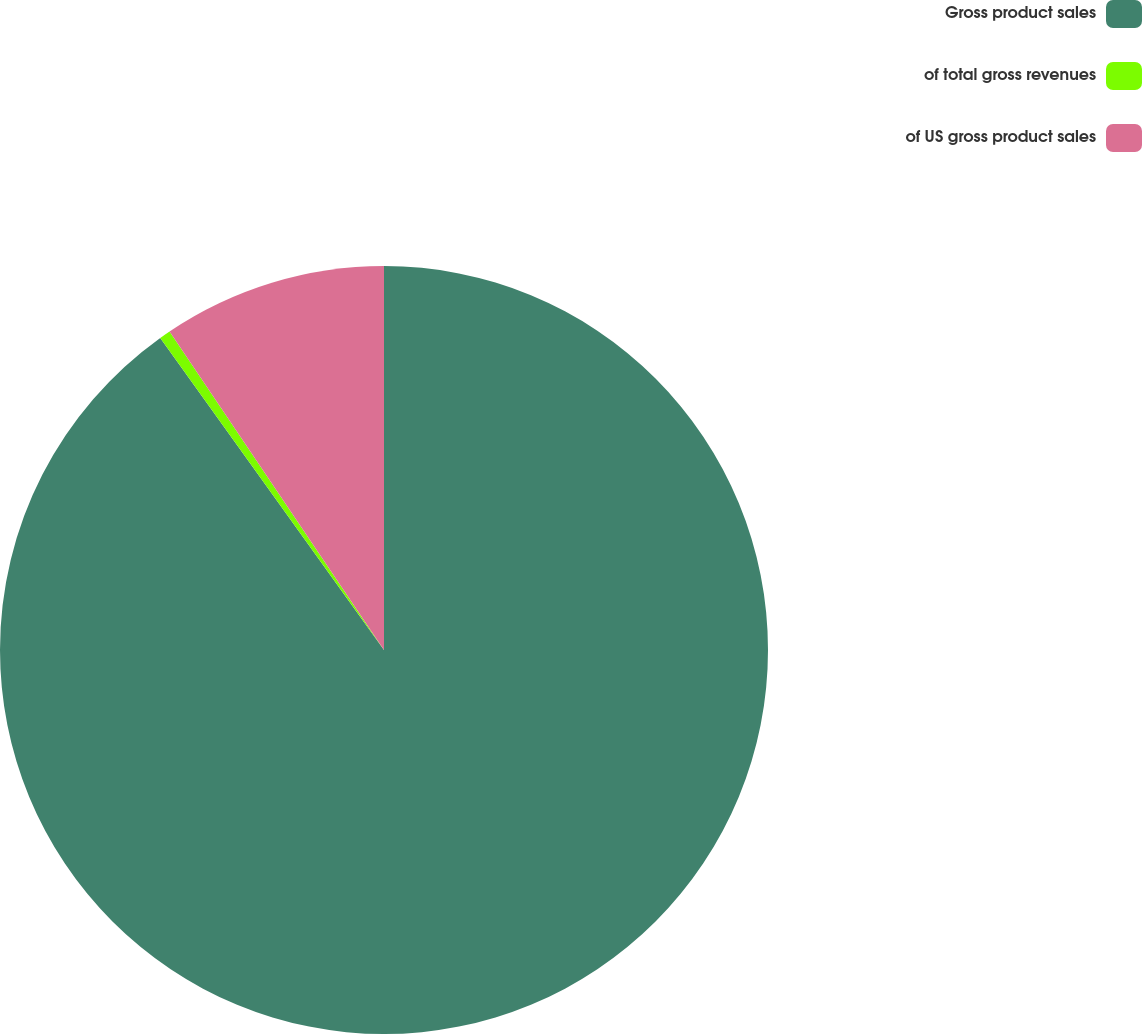Convert chart to OTSL. <chart><loc_0><loc_0><loc_500><loc_500><pie_chart><fcel>Gross product sales<fcel>of total gross revenues<fcel>of US gross product sales<nl><fcel>90.1%<fcel>0.47%<fcel>9.43%<nl></chart> 